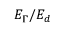Convert formula to latex. <formula><loc_0><loc_0><loc_500><loc_500>E _ { \Gamma } / E _ { d }</formula> 